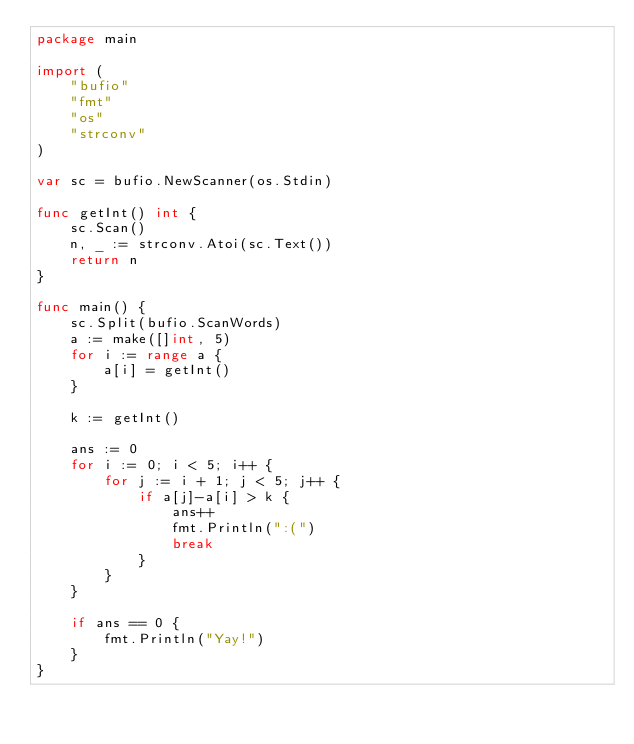Convert code to text. <code><loc_0><loc_0><loc_500><loc_500><_Go_>package main

import (
	"bufio"
	"fmt"
	"os"
	"strconv"
)

var sc = bufio.NewScanner(os.Stdin)

func getInt() int {
	sc.Scan()
	n, _ := strconv.Atoi(sc.Text())
	return n
}

func main() {
	sc.Split(bufio.ScanWords)
	a := make([]int, 5)
	for i := range a {
		a[i] = getInt()
	}

	k := getInt()

	ans := 0
	for i := 0; i < 5; i++ {
		for j := i + 1; j < 5; j++ {
			if a[j]-a[i] > k {
				ans++
				fmt.Println(":(")
				break
			}
		}
	}

	if ans == 0 {
		fmt.Println("Yay!")
	}
}
</code> 